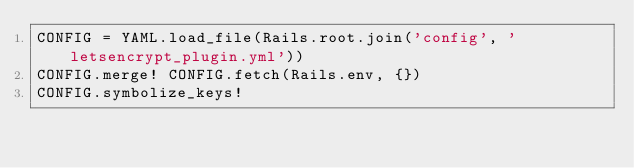<code> <loc_0><loc_0><loc_500><loc_500><_Ruby_>CONFIG = YAML.load_file(Rails.root.join('config', 'letsencrypt_plugin.yml'))
CONFIG.merge! CONFIG.fetch(Rails.env, {})
CONFIG.symbolize_keys!</code> 